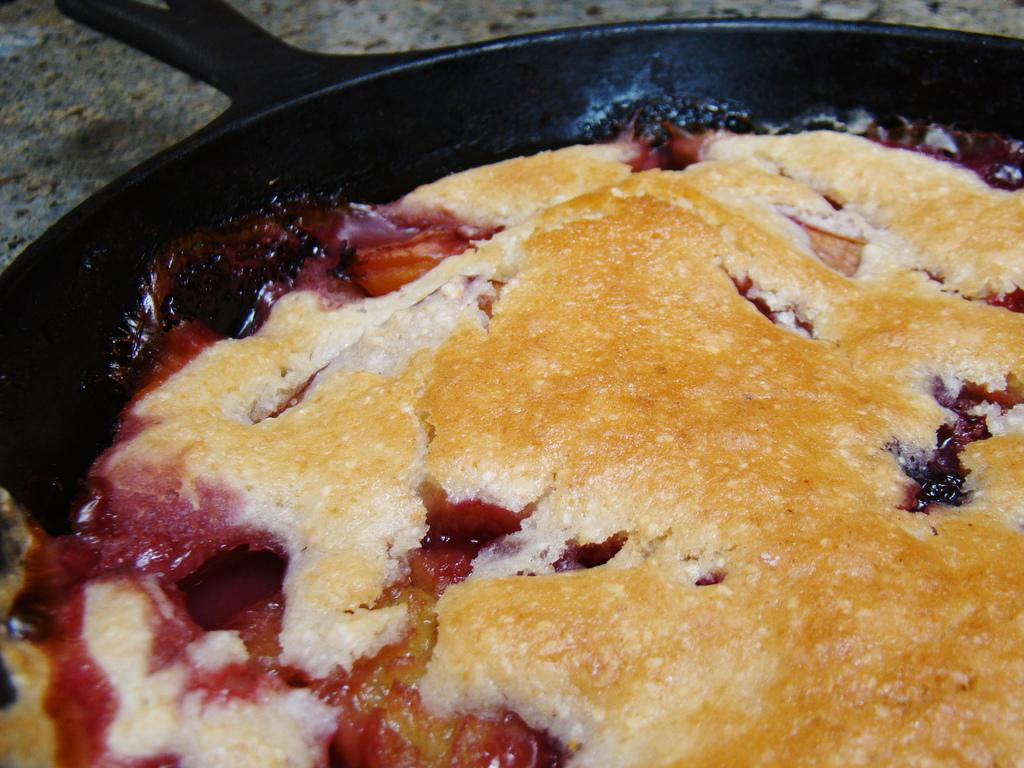What type of food is visible in the image? There is a pizza in a pan in the image. Where is the pizza located? The pizza is on a table. In which setting is the pizza placed? The image is taken in a room. What type of pets can be seen playing with a bead in the image? There are no pets or beads present in the image; it features a pizza on a table in a room. 